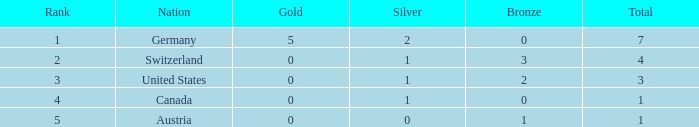Parse the full table. {'header': ['Rank', 'Nation', 'Gold', 'Silver', 'Bronze', 'Total'], 'rows': [['1', 'Germany', '5', '2', '0', '7'], ['2', 'Switzerland', '0', '1', '3', '4'], ['3', 'United States', '0', '1', '2', '3'], ['4', 'Canada', '0', '1', '0', '1'], ['5', 'Austria', '0', '0', '1', '1']]} When the quantity of gold in austria is less than 0, what is the entire total amount? None. 